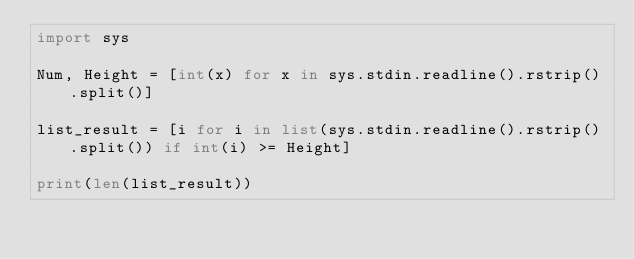Convert code to text. <code><loc_0><loc_0><loc_500><loc_500><_Python_>import sys

Num, Height = [int(x) for x in sys.stdin.readline().rstrip().split()]

list_result = [i for i in list(sys.stdin.readline().rstrip().split()) if int(i) >= Height]

print(len(list_result))</code> 